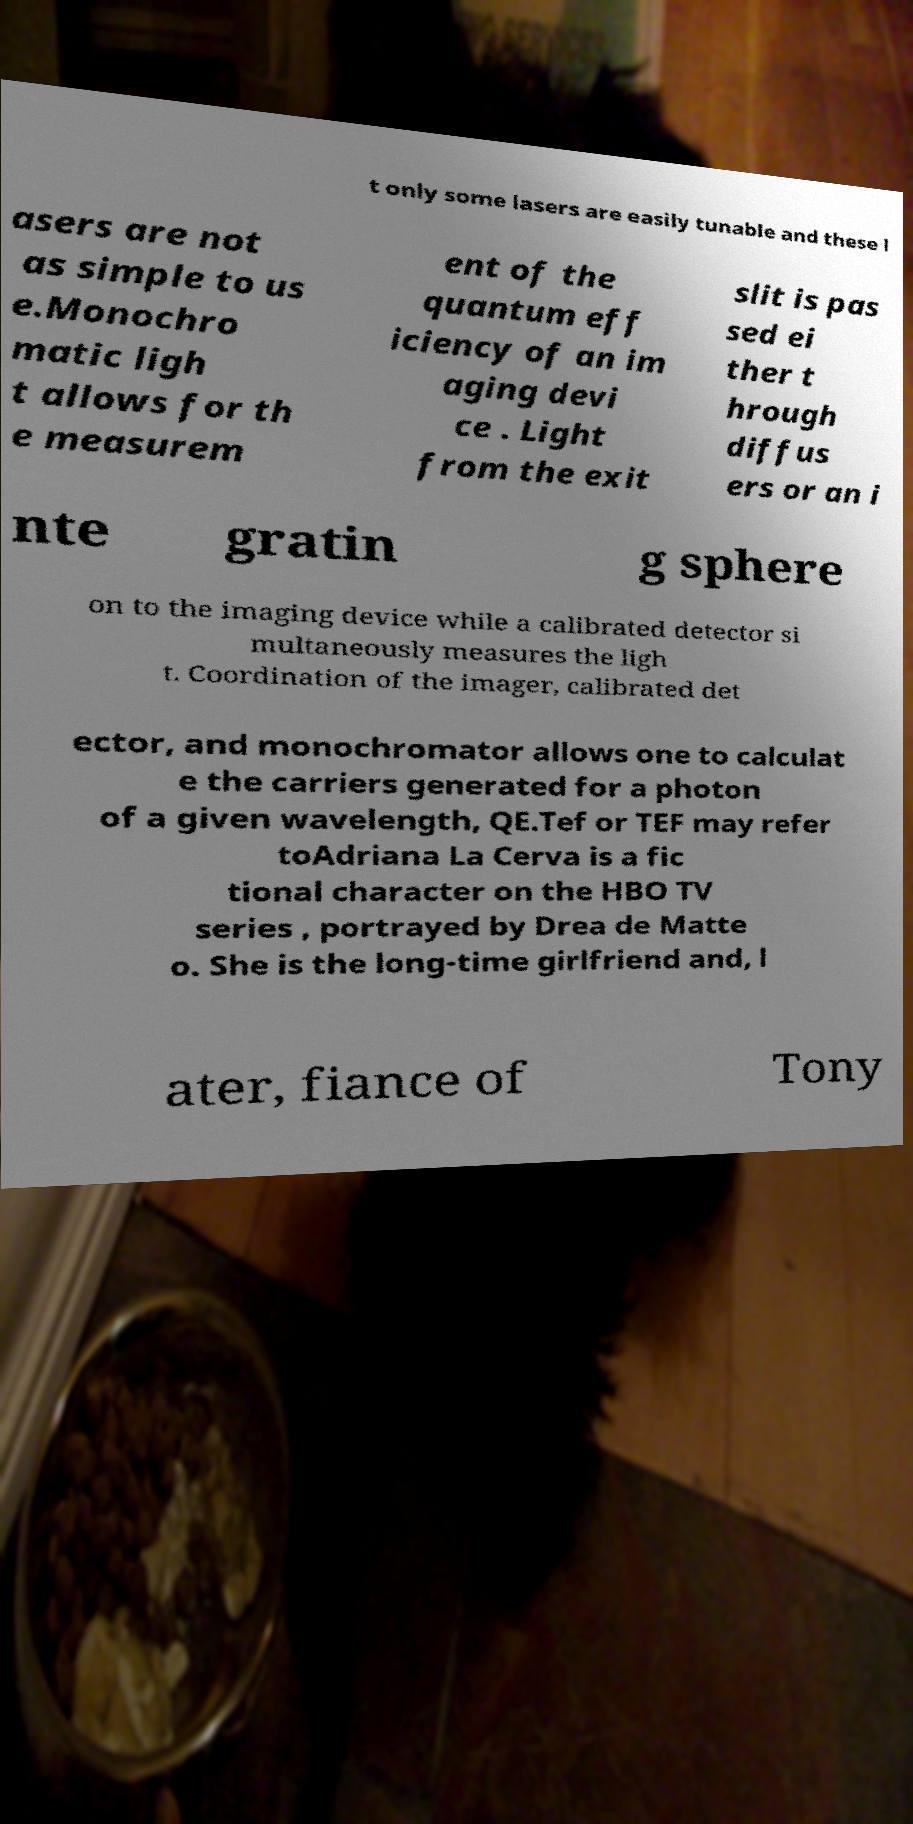Could you assist in decoding the text presented in this image and type it out clearly? t only some lasers are easily tunable and these l asers are not as simple to us e.Monochro matic ligh t allows for th e measurem ent of the quantum eff iciency of an im aging devi ce . Light from the exit slit is pas sed ei ther t hrough diffus ers or an i nte gratin g sphere on to the imaging device while a calibrated detector si multaneously measures the ligh t. Coordination of the imager, calibrated det ector, and monochromator allows one to calculat e the carriers generated for a photon of a given wavelength, QE.Tef or TEF may refer toAdriana La Cerva is a fic tional character on the HBO TV series , portrayed by Drea de Matte o. She is the long-time girlfriend and, l ater, fiance of Tony 